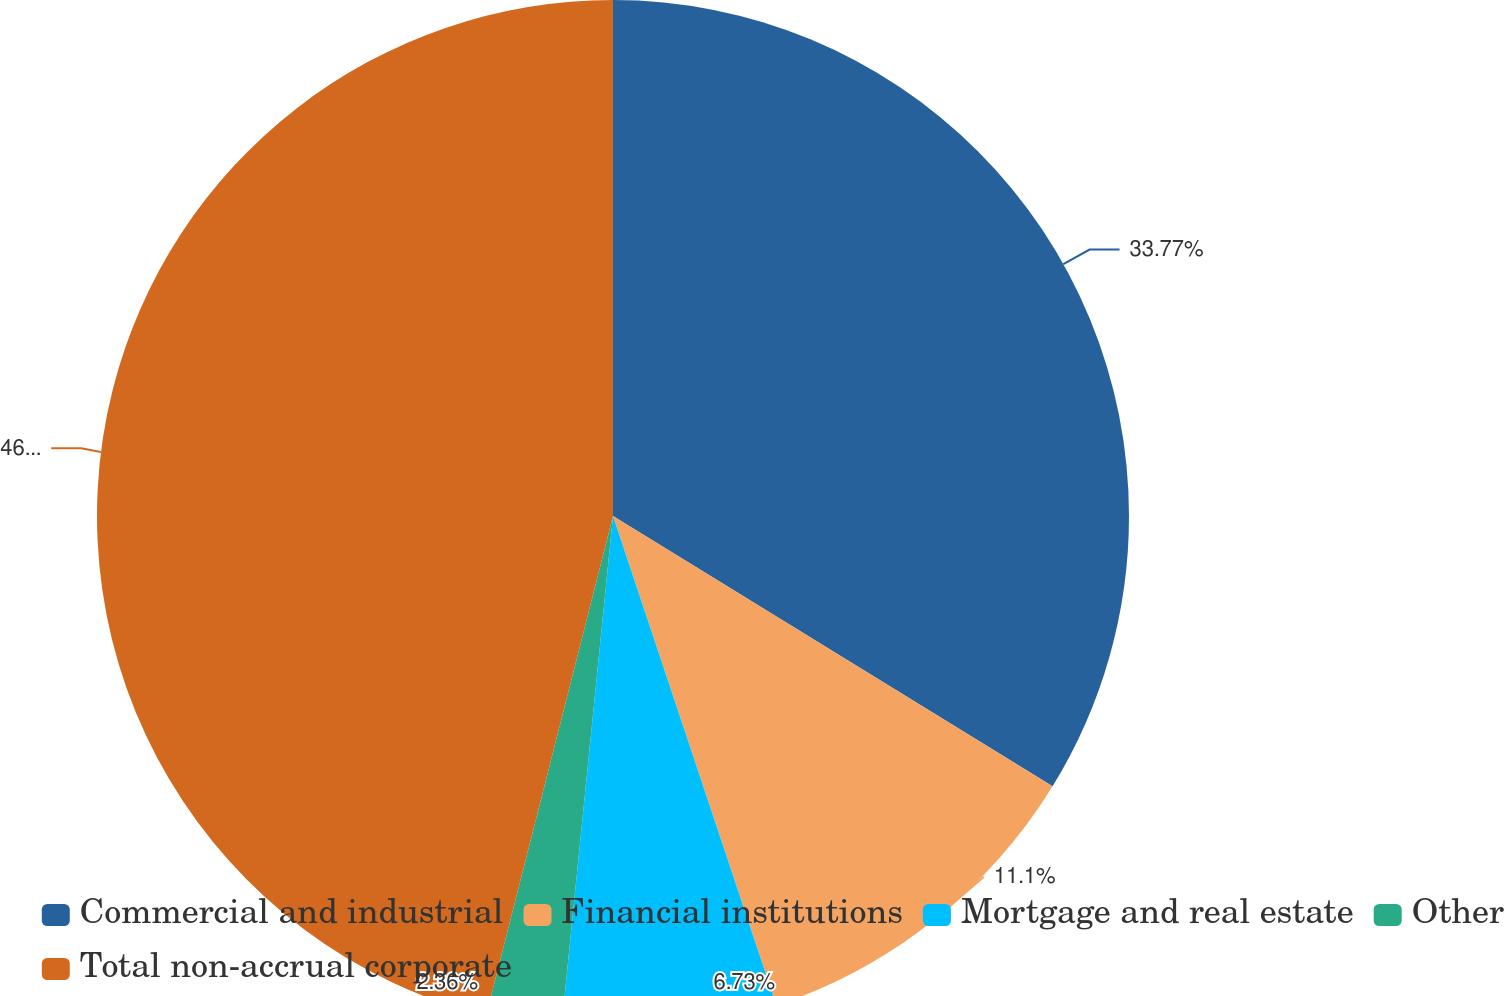Convert chart to OTSL. <chart><loc_0><loc_0><loc_500><loc_500><pie_chart><fcel>Commercial and industrial<fcel>Financial institutions<fcel>Mortgage and real estate<fcel>Other<fcel>Total non-accrual corporate<nl><fcel>33.78%<fcel>11.1%<fcel>6.73%<fcel>2.36%<fcel>46.05%<nl></chart> 